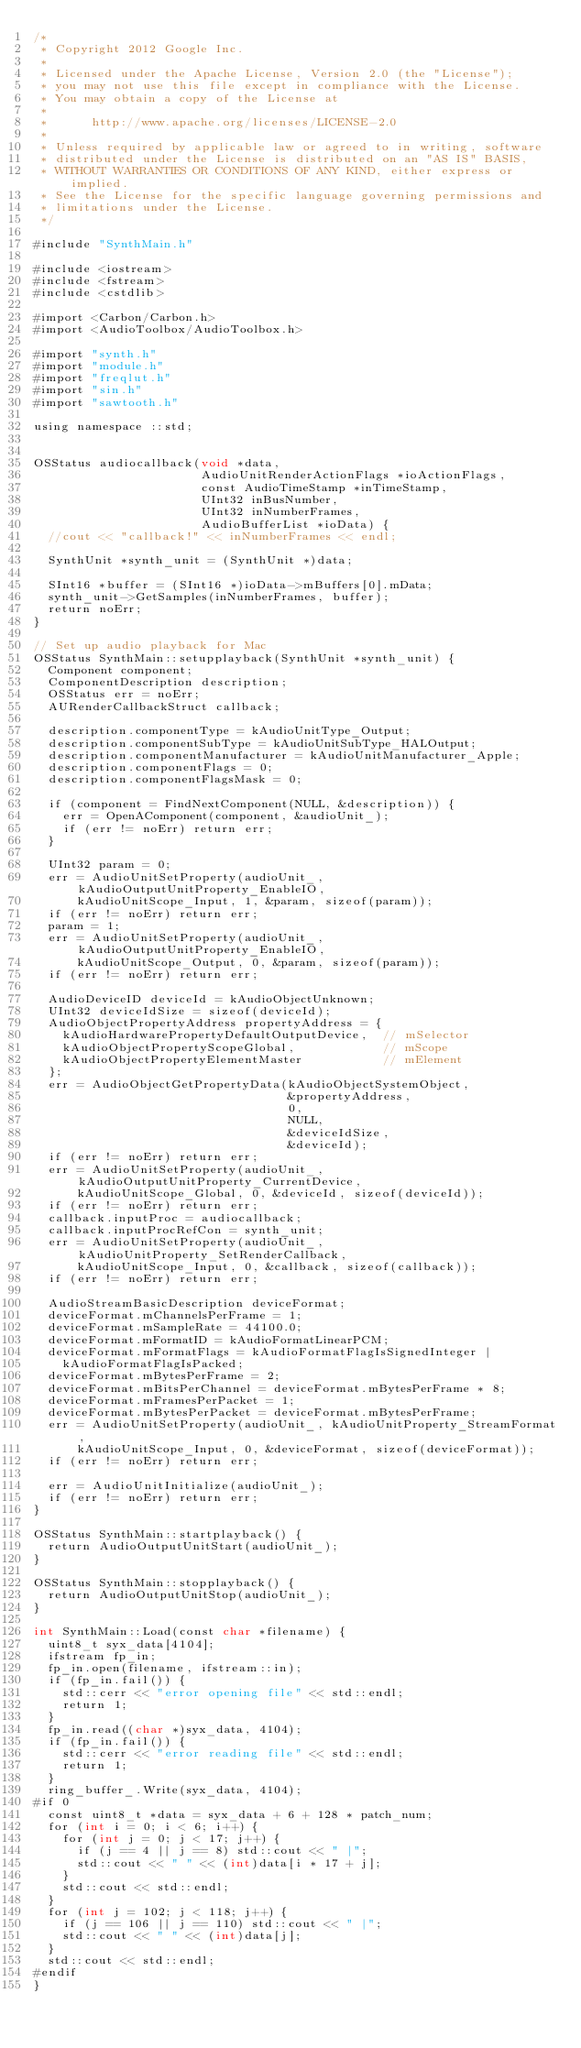<code> <loc_0><loc_0><loc_500><loc_500><_ObjectiveC_>/*
 * Copyright 2012 Google Inc.
 * 
 * Licensed under the Apache License, Version 2.0 (the "License");
 * you may not use this file except in compliance with the License.
 * You may obtain a copy of the License at
 * 
 *      http://www.apache.org/licenses/LICENSE-2.0
 * 
 * Unless required by applicable law or agreed to in writing, software
 * distributed under the License is distributed on an "AS IS" BASIS,
 * WITHOUT WARRANTIES OR CONDITIONS OF ANY KIND, either express or implied.
 * See the License for the specific language governing permissions and
 * limitations under the License.
 */

#include "SynthMain.h"

#include <iostream>
#include <fstream>
#include <cstdlib>

#import <Carbon/Carbon.h>
#import <AudioToolbox/AudioToolbox.h>

#import "synth.h"
#import "module.h"
#import "freqlut.h"
#import "sin.h"
#import "sawtooth.h"

using namespace ::std;


OSStatus audiocallback(void *data,
                       AudioUnitRenderActionFlags *ioActionFlags,
                       const AudioTimeStamp *inTimeStamp,
                       UInt32 inBusNumber,
                       UInt32 inNumberFrames,
                       AudioBufferList *ioData) {
  //cout << "callback!" << inNumberFrames << endl;

  SynthUnit *synth_unit = (SynthUnit *)data;

  SInt16 *buffer = (SInt16 *)ioData->mBuffers[0].mData;
  synth_unit->GetSamples(inNumberFrames, buffer);
  return noErr;
}

// Set up audio playback for Mac
OSStatus SynthMain::setupplayback(SynthUnit *synth_unit) {
  Component component;
  ComponentDescription description;
  OSStatus err = noErr;
  AURenderCallbackStruct callback;

  description.componentType = kAudioUnitType_Output;
  description.componentSubType = kAudioUnitSubType_HALOutput;
  description.componentManufacturer = kAudioUnitManufacturer_Apple;
  description.componentFlags = 0;
  description.componentFlagsMask = 0;
  
  if (component = FindNextComponent(NULL, &description)) {
    err = OpenAComponent(component, &audioUnit_);
    if (err != noErr) return err;
  }

  UInt32 param = 0;
  err = AudioUnitSetProperty(audioUnit_, kAudioOutputUnitProperty_EnableIO,
      kAudioUnitScope_Input, 1, &param, sizeof(param));
  if (err != noErr) return err;
  param = 1;
  err = AudioUnitSetProperty(audioUnit_, kAudioOutputUnitProperty_EnableIO,
      kAudioUnitScope_Output, 0, &param, sizeof(param));
  if (err != noErr) return err;
  
  AudioDeviceID deviceId = kAudioObjectUnknown;
  UInt32 deviceIdSize = sizeof(deviceId);
  AudioObjectPropertyAddress propertyAddress = {
    kAudioHardwarePropertyDefaultOutputDevice,  // mSelector
    kAudioObjectPropertyScopeGlobal,            // mScope
    kAudioObjectPropertyElementMaster           // mElement
  };
  err = AudioObjectGetPropertyData(kAudioObjectSystemObject,
                                   &propertyAddress,
                                   0,
                                   NULL,
                                   &deviceIdSize,
                                   &deviceId);
  if (err != noErr) return err;
  err = AudioUnitSetProperty(audioUnit_, kAudioOutputUnitProperty_CurrentDevice,
      kAudioUnitScope_Global, 0, &deviceId, sizeof(deviceId));
  if (err != noErr) return err;
  callback.inputProc = audiocallback;
  callback.inputProcRefCon = synth_unit;
  err = AudioUnitSetProperty(audioUnit_, kAudioUnitProperty_SetRenderCallback,
      kAudioUnitScope_Input, 0, &callback, sizeof(callback));
  if (err != noErr) return err;
  
  AudioStreamBasicDescription deviceFormat;
  deviceFormat.mChannelsPerFrame = 1;
  deviceFormat.mSampleRate = 44100.0;
  deviceFormat.mFormatID = kAudioFormatLinearPCM;
  deviceFormat.mFormatFlags = kAudioFormatFlagIsSignedInteger |
    kAudioFormatFlagIsPacked;
  deviceFormat.mBytesPerFrame = 2;
  deviceFormat.mBitsPerChannel = deviceFormat.mBytesPerFrame * 8;
  deviceFormat.mFramesPerPacket = 1;
  deviceFormat.mBytesPerPacket = deviceFormat.mBytesPerFrame;
  err = AudioUnitSetProperty(audioUnit_, kAudioUnitProperty_StreamFormat,
      kAudioUnitScope_Input, 0, &deviceFormat, sizeof(deviceFormat));
  if (err != noErr) return err;
  
  err = AudioUnitInitialize(audioUnit_);
  if (err != noErr) return err;
}

OSStatus SynthMain::startplayback() {
  return AudioOutputUnitStart(audioUnit_);
}

OSStatus SynthMain::stopplayback() {
  return AudioOutputUnitStop(audioUnit_);
}

int SynthMain::Load(const char *filename) {
  uint8_t syx_data[4104];
  ifstream fp_in;
  fp_in.open(filename, ifstream::in);
  if (fp_in.fail()) {
    std::cerr << "error opening file" << std::endl;
    return 1;
  }
  fp_in.read((char *)syx_data, 4104);
  if (fp_in.fail()) {
    std::cerr << "error reading file" << std::endl;
    return 1;
  }
  ring_buffer_.Write(syx_data, 4104);
#if 0
  const uint8_t *data = syx_data + 6 + 128 * patch_num;
  for (int i = 0; i < 6; i++) {
    for (int j = 0; j < 17; j++) {
      if (j == 4 || j == 8) std::cout << " |";
      std::cout << " " << (int)data[i * 17 + j];
    }
    std::cout << std::endl;
  }
  for (int j = 102; j < 118; j++) {
    if (j == 106 || j == 110) std::cout << " |";
    std::cout << " " << (int)data[j];
  }
  std::cout << std::endl;
#endif
}
</code> 